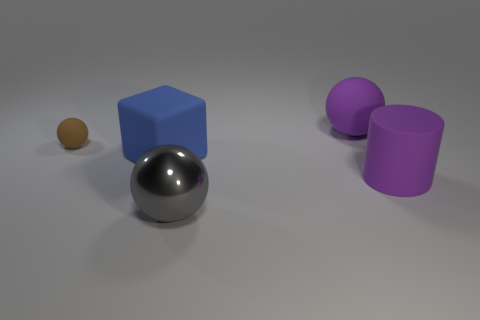What can you tell me about the lighting in this scene? The lighting in the scene appears to be soft and diffused, with shadows indicating an overhead source. The way the light interacts with the objects suggests a single light source providing even illumination across the scene. 